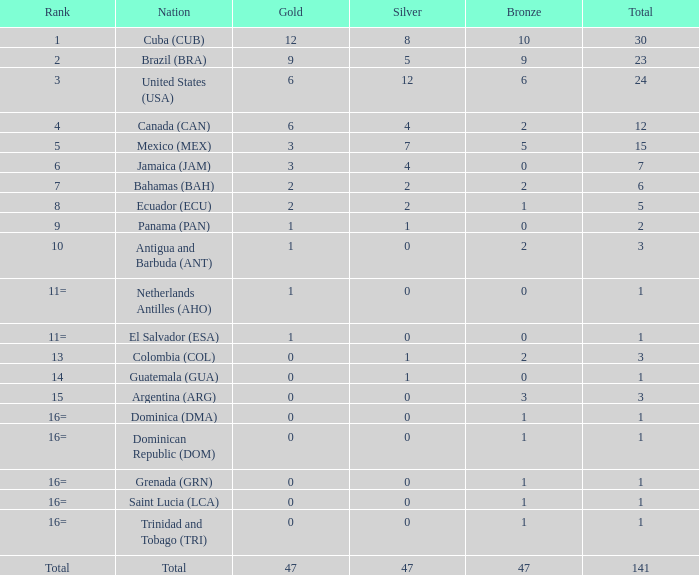What is the typical silver quantity for cases with greater than 0 gold, a 1st rank, and a total under 30? None. 